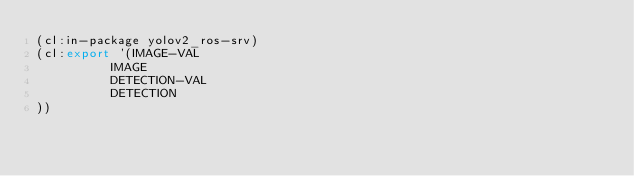<code> <loc_0><loc_0><loc_500><loc_500><_Lisp_>(cl:in-package yolov2_ros-srv)
(cl:export '(IMAGE-VAL
          IMAGE
          DETECTION-VAL
          DETECTION
))</code> 